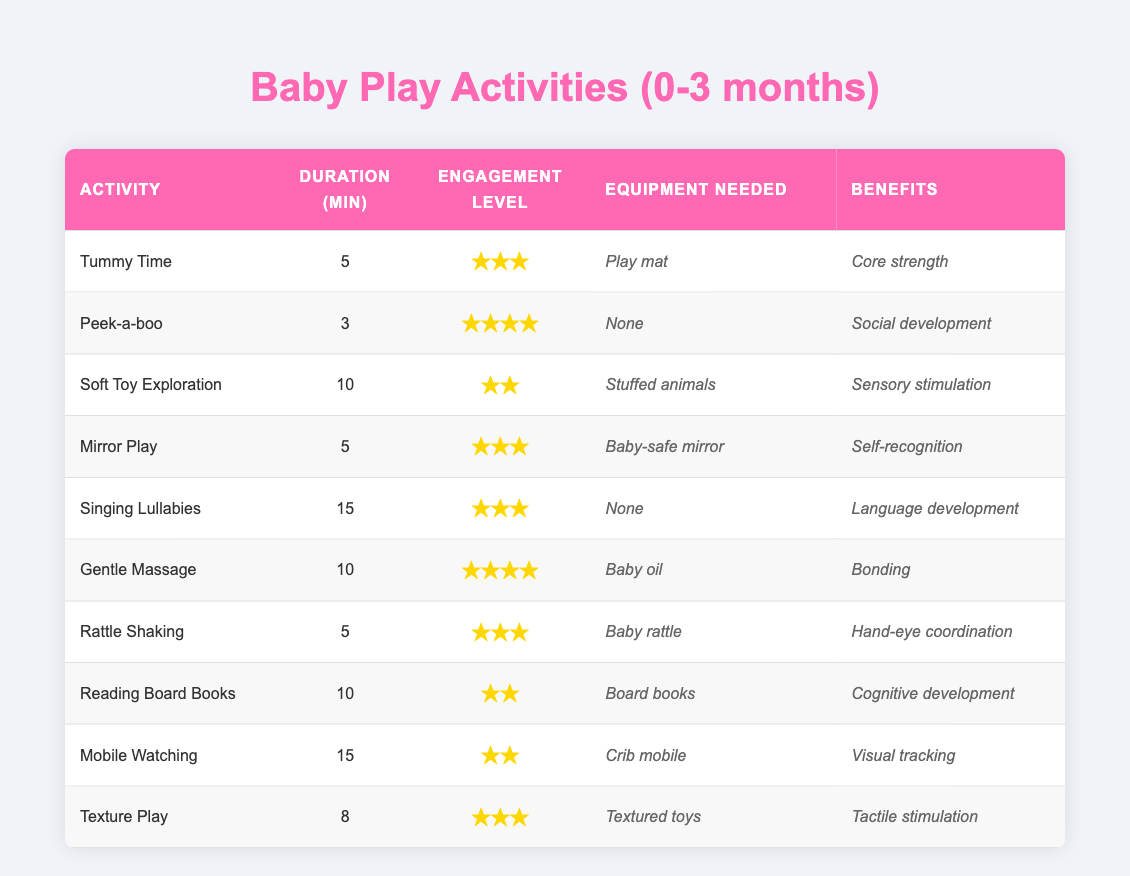What is the duration of the activity "Gentle Massage"? The table lists the duration for "Gentle Massage" directly under the Duration (min) column, which shows a value of 10.
Answer: 10 Which activity has the highest engagement level? From the Engagement Level column, the category is ranked based on the number of stars. Looking through the column, "Peek-a-boo" and "Gentle Massage" both have the highest engagement level at 4 stars.
Answer: Peek-a-boo and Gentle Massage What is the average duration of all the activities listed? To find the average duration, first sum all the durations: 5 + 3 + 10 + 5 + 15 + 10 + 5 + 10 + 15 + 8 = 86. Then divide that sum by the number of activities, which is 10: 86 / 10 = 8.6.
Answer: 8.6 Does the activity "Reading Board Books" have a higher engagement level than "Mobile Watching"? By checking the Engagement Level column, "Reading Board Books" has 2 stars while "Mobile Watching" also has 2 stars, indicating that their engagement levels are equal.
Answer: No Which activity has the longest duration and what is its engagement level? Scanning the Duration column, "Singing Lullabies" and "Mobile Watching" both list a duration of 15 minutes, but "Singing Lullabies" has a higher engagement level of 3 stars compared to 2 for "Mobile Watching." Therefore, the longest duration belongs to "Singing Lullabies" with its corresponding engagement level being 3.
Answer: Singing Lullabies, engagement level 3 How many activities require equipment? The table lists the equipment needed for each activity. Out of the 10 activities, 7 mention equipment while 3 do not. So, by counting those entries, the total is 7 activities that require equipment.
Answer: 7 